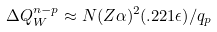<formula> <loc_0><loc_0><loc_500><loc_500>\Delta Q ^ { n - p } _ { W } \approx N ( Z \alpha ) ^ { 2 } ( . 2 2 1 \epsilon ) / q _ { p } \,</formula> 